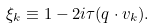<formula> <loc_0><loc_0><loc_500><loc_500>\xi _ { k } \equiv 1 - 2 i \tau ( q \cdot v _ { k } ) .</formula> 